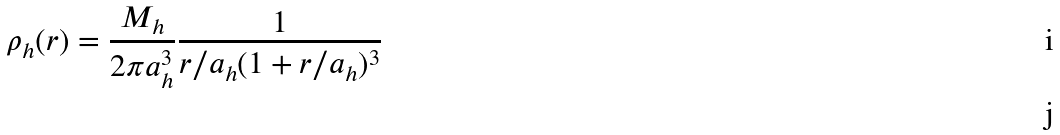Convert formula to latex. <formula><loc_0><loc_0><loc_500><loc_500>\rho _ { h } ( r ) = \frac { M _ { h } } { 2 \pi a _ { h } ^ { 3 } } \frac { 1 } { r / a _ { h } ( 1 + r / a _ { h } ) ^ { 3 } } \\</formula> 